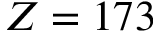<formula> <loc_0><loc_0><loc_500><loc_500>Z = 1 7 3</formula> 